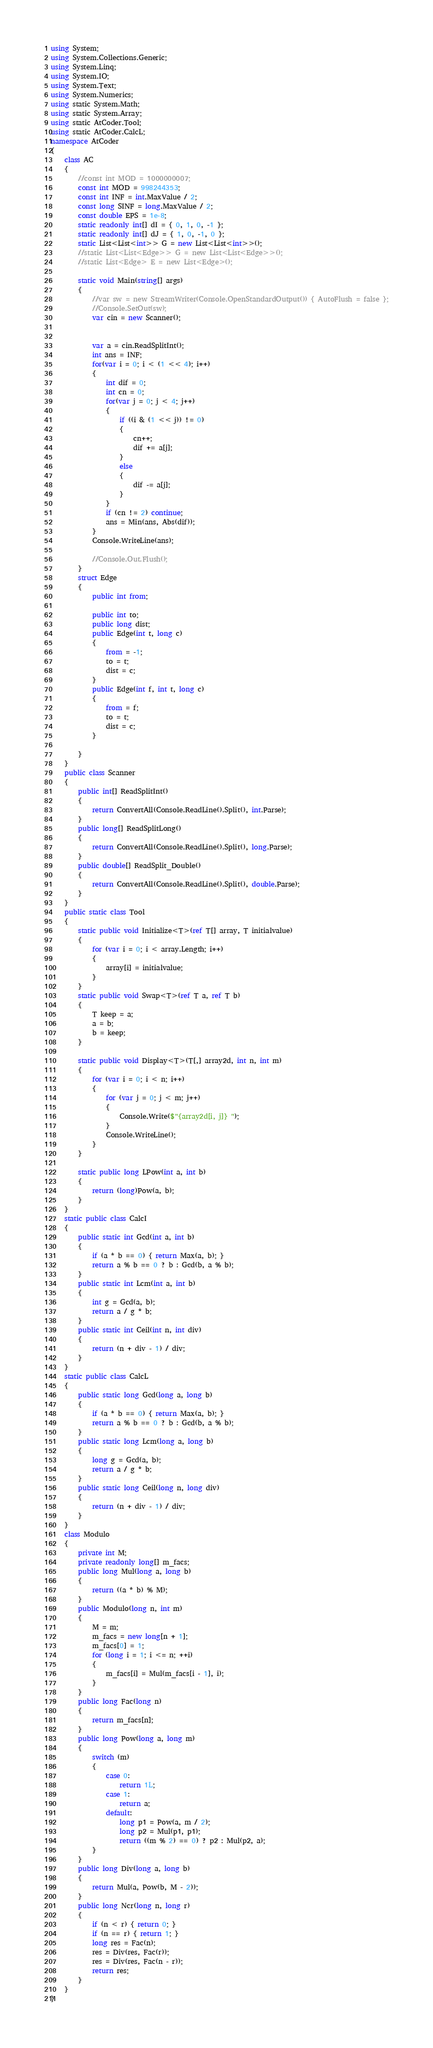<code> <loc_0><loc_0><loc_500><loc_500><_C#_>using System;
using System.Collections.Generic;
using System.Linq;
using System.IO;
using System.Text;
using System.Numerics;
using static System.Math;
using static System.Array;
using static AtCoder.Tool;
using static AtCoder.CalcL;
namespace AtCoder
{
    class AC
    {
        //const int MOD = 1000000007;
        const int MOD = 998244353;
        const int INF = int.MaxValue / 2;
        const long SINF = long.MaxValue / 2;
        const double EPS = 1e-8;
        static readonly int[] dI = { 0, 1, 0, -1 };
        static readonly int[] dJ = { 1, 0, -1, 0 };
        static List<List<int>> G = new List<List<int>>();
        //static List<List<Edge>> G = new List<List<Edge>>();
        //static List<Edge> E = new List<Edge>();
        
        static void Main(string[] args)
        {
            //var sw = new StreamWriter(Console.OpenStandardOutput()) { AutoFlush = false };
            //Console.SetOut(sw);
            var cin = new Scanner();

            
            var a = cin.ReadSplitInt();
            int ans = INF;
            for(var i = 0; i < (1 << 4); i++)
            {
                int dif = 0;
                int cn = 0;
                for(var j = 0; j < 4; j++)
                {
                    if ((i & (1 << j)) != 0)
                    {
                        cn++;
                        dif += a[j];
                    }
                    else
                    {
                        dif -= a[j];
                    }
                }
                if (cn != 2) continue;
                ans = Min(ans, Abs(dif));
            }
            Console.WriteLine(ans);

            //Console.Out.Flush();
        }
        struct Edge
        {
            public int from;

            public int to;
            public long dist;
            public Edge(int t, long c)
            {
                from = -1;
                to = t;
                dist = c;
            }
            public Edge(int f, int t, long c)
            {
                from = f;
                to = t;
                dist = c;
            }

        }
    }
    public class Scanner
    {
        public int[] ReadSplitInt()
        {
            return ConvertAll(Console.ReadLine().Split(), int.Parse);
        }
        public long[] ReadSplitLong()
        {
            return ConvertAll(Console.ReadLine().Split(), long.Parse);
        }
        public double[] ReadSplit_Double()
        {
            return ConvertAll(Console.ReadLine().Split(), double.Parse);
        }
    }
    public static class Tool
    {
        static public void Initialize<T>(ref T[] array, T initialvalue)
        {
            for (var i = 0; i < array.Length; i++)
            {
                array[i] = initialvalue;
            }
        }
        static public void Swap<T>(ref T a, ref T b)
        {
            T keep = a;
            a = b;
            b = keep;
        }

        static public void Display<T>(T[,] array2d, int n, int m)
        {
            for (var i = 0; i < n; i++)
            {
                for (var j = 0; j < m; j++)
                {
                    Console.Write($"{array2d[i, j]} ");
                }
                Console.WriteLine();
            }
        }

        static public long LPow(int a, int b)
        {
            return (long)Pow(a, b);
        }
    }
    static public class CalcI
    {
        public static int Gcd(int a, int b)
        {
            if (a * b == 0) { return Max(a, b); }
            return a % b == 0 ? b : Gcd(b, a % b);
        }
        public static int Lcm(int a, int b)
        {
            int g = Gcd(a, b);
            return a / g * b;
        }
        public static int Ceil(int n, int div)
        {
            return (n + div - 1) / div;
        }
    }
    static public class CalcL
    {
        public static long Gcd(long a, long b)
        {
            if (a * b == 0) { return Max(a, b); }
            return a % b == 0 ? b : Gcd(b, a % b);
        }
        public static long Lcm(long a, long b)
        {
            long g = Gcd(a, b);
            return a / g * b;
        }
        public static long Ceil(long n, long div)
        {
            return (n + div - 1) / div;
        }
    }
    class Modulo
    {
        private int M;
        private readonly long[] m_facs;
        public long Mul(long a, long b)
        {
            return ((a * b) % M);
        }
        public Modulo(long n, int m)
        {
            M = m;
            m_facs = new long[n + 1];
            m_facs[0] = 1;
            for (long i = 1; i <= n; ++i)
            {
                m_facs[i] = Mul(m_facs[i - 1], i);
            }
        }
        public long Fac(long n)
        {
            return m_facs[n];
        }
        public long Pow(long a, long m)
        {
            switch (m)
            {
                case 0:
                    return 1L;
                case 1:
                    return a;
                default:
                    long p1 = Pow(a, m / 2);
                    long p2 = Mul(p1, p1);
                    return ((m % 2) == 0) ? p2 : Mul(p2, a);
            }
        }
        public long Div(long a, long b)
        {
            return Mul(a, Pow(b, M - 2));
        }
        public long Ncr(long n, long r)
        {
            if (n < r) { return 0; }
            if (n == r) { return 1; }
            long res = Fac(n);
            res = Div(res, Fac(r));
            res = Div(res, Fac(n - r));
            return res;
        }
    }
}

</code> 